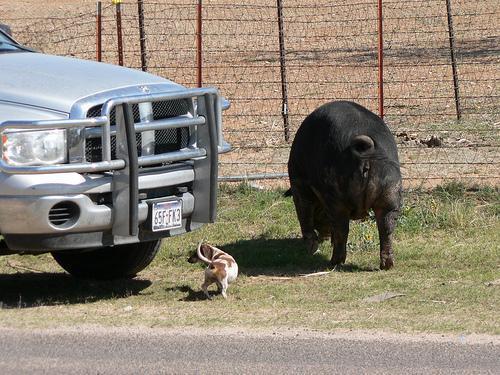How many animals?
Give a very brief answer. 2. 